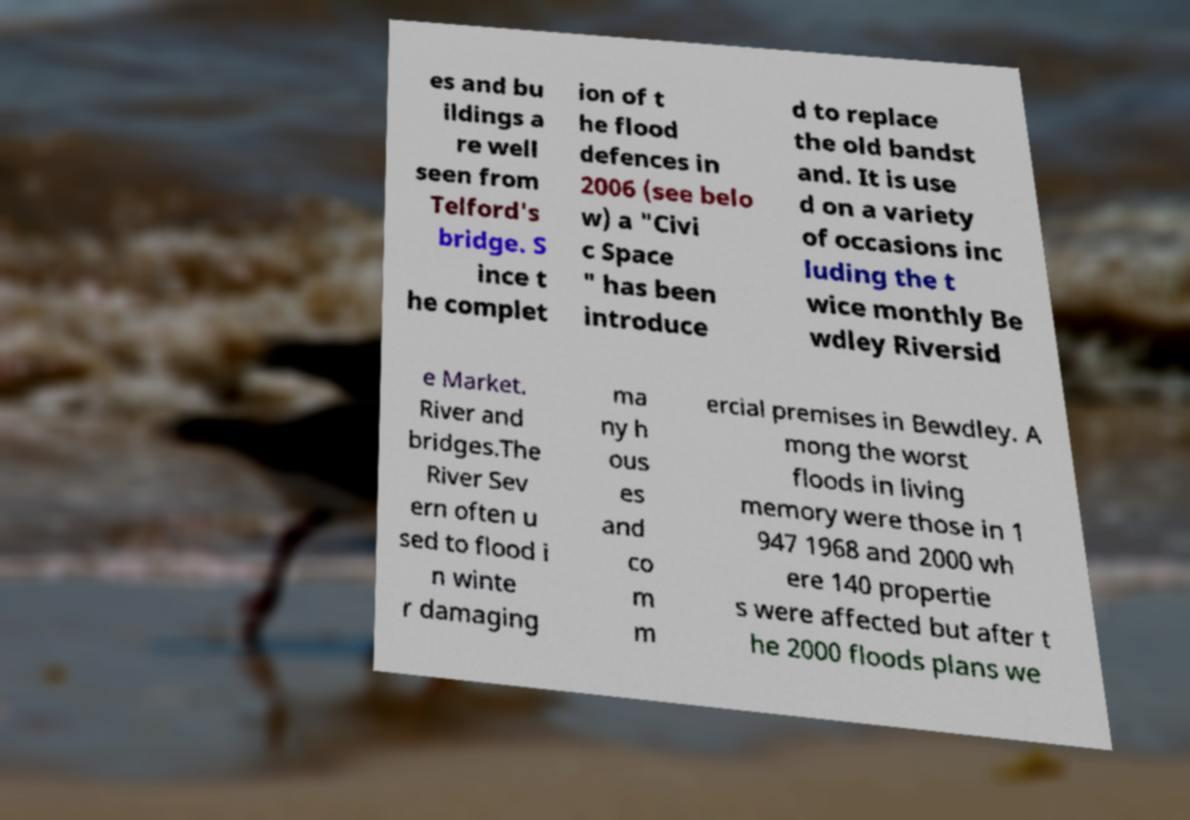Could you extract and type out the text from this image? es and bu ildings a re well seen from Telford's bridge. S ince t he complet ion of t he flood defences in 2006 (see belo w) a "Civi c Space " has been introduce d to replace the old bandst and. It is use d on a variety of occasions inc luding the t wice monthly Be wdley Riversid e Market. River and bridges.The River Sev ern often u sed to flood i n winte r damaging ma ny h ous es and co m m ercial premises in Bewdley. A mong the worst floods in living memory were those in 1 947 1968 and 2000 wh ere 140 propertie s were affected but after t he 2000 floods plans we 